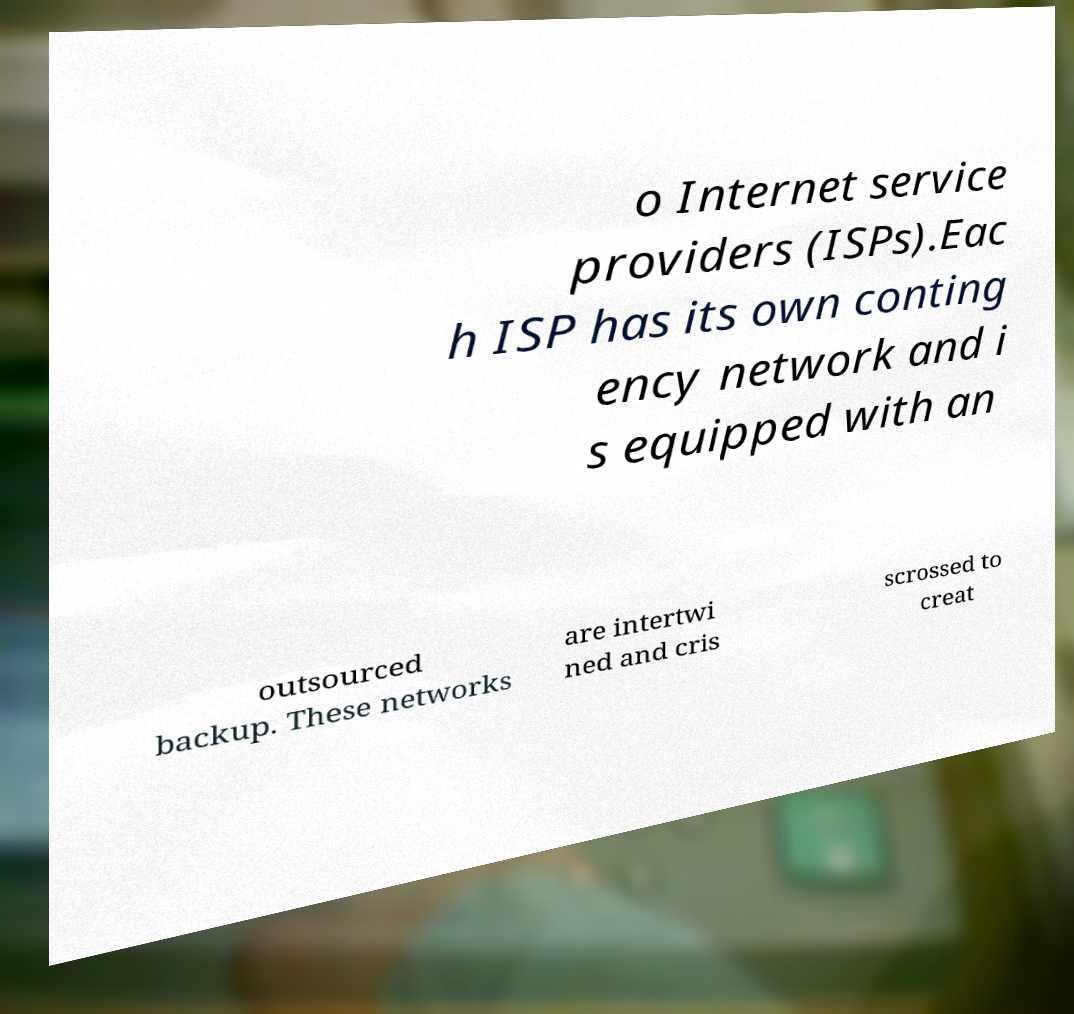What messages or text are displayed in this image? I need them in a readable, typed format. o Internet service providers (ISPs).Eac h ISP has its own conting ency network and i s equipped with an outsourced backup. These networks are intertwi ned and cris scrossed to creat 